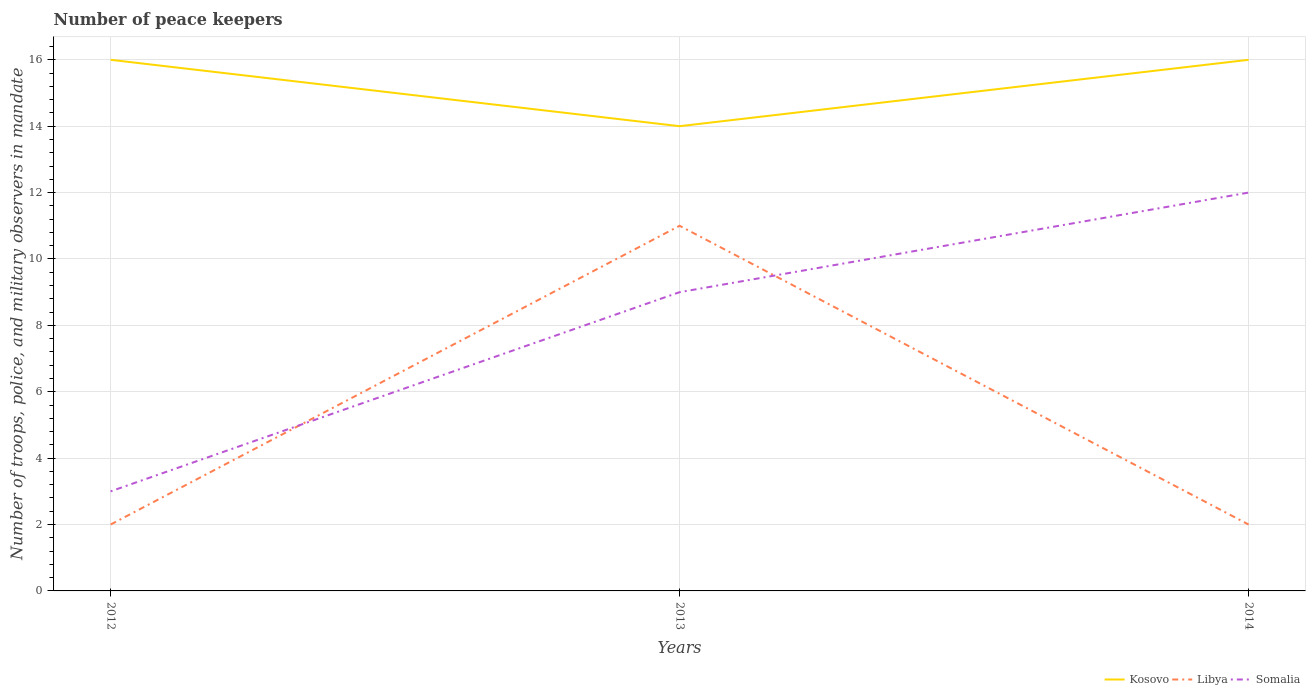How many different coloured lines are there?
Provide a short and direct response. 3. Does the line corresponding to Kosovo intersect with the line corresponding to Libya?
Give a very brief answer. No. In which year was the number of peace keepers in in Somalia maximum?
Your answer should be very brief. 2012. What is the total number of peace keepers in in Somalia in the graph?
Offer a terse response. -6. What is the difference between the highest and the second highest number of peace keepers in in Somalia?
Your answer should be compact. 9. How many years are there in the graph?
Provide a succinct answer. 3. What is the difference between two consecutive major ticks on the Y-axis?
Your answer should be compact. 2. Does the graph contain grids?
Ensure brevity in your answer.  Yes. Where does the legend appear in the graph?
Offer a very short reply. Bottom right. How many legend labels are there?
Provide a short and direct response. 3. What is the title of the graph?
Offer a very short reply. Number of peace keepers. Does "Namibia" appear as one of the legend labels in the graph?
Your answer should be very brief. No. What is the label or title of the X-axis?
Offer a terse response. Years. What is the label or title of the Y-axis?
Give a very brief answer. Number of troops, police, and military observers in mandate. What is the Number of troops, police, and military observers in mandate of Kosovo in 2012?
Give a very brief answer. 16. What is the Number of troops, police, and military observers in mandate of Libya in 2012?
Offer a very short reply. 2. What is the Number of troops, police, and military observers in mandate of Somalia in 2012?
Provide a short and direct response. 3. What is the Number of troops, police, and military observers in mandate in Kosovo in 2013?
Offer a terse response. 14. What is the Number of troops, police, and military observers in mandate in Libya in 2013?
Your answer should be compact. 11. What is the Number of troops, police, and military observers in mandate in Libya in 2014?
Offer a terse response. 2. Across all years, what is the maximum Number of troops, police, and military observers in mandate of Libya?
Offer a very short reply. 11. Across all years, what is the minimum Number of troops, police, and military observers in mandate of Libya?
Keep it short and to the point. 2. What is the total Number of troops, police, and military observers in mandate in Somalia in the graph?
Offer a very short reply. 24. What is the difference between the Number of troops, police, and military observers in mandate of Somalia in 2012 and that in 2013?
Ensure brevity in your answer.  -6. What is the difference between the Number of troops, police, and military observers in mandate of Kosovo in 2012 and that in 2014?
Your response must be concise. 0. What is the difference between the Number of troops, police, and military observers in mandate of Libya in 2012 and that in 2014?
Keep it short and to the point. 0. What is the difference between the Number of troops, police, and military observers in mandate in Somalia in 2012 and that in 2014?
Provide a short and direct response. -9. What is the difference between the Number of troops, police, and military observers in mandate in Kosovo in 2012 and the Number of troops, police, and military observers in mandate in Libya in 2013?
Make the answer very short. 5. What is the difference between the Number of troops, police, and military observers in mandate in Kosovo in 2012 and the Number of troops, police, and military observers in mandate in Somalia in 2013?
Keep it short and to the point. 7. What is the difference between the Number of troops, police, and military observers in mandate in Kosovo in 2012 and the Number of troops, police, and military observers in mandate in Somalia in 2014?
Your response must be concise. 4. What is the difference between the Number of troops, police, and military observers in mandate of Kosovo in 2013 and the Number of troops, police, and military observers in mandate of Libya in 2014?
Provide a succinct answer. 12. What is the difference between the Number of troops, police, and military observers in mandate in Libya in 2013 and the Number of troops, police, and military observers in mandate in Somalia in 2014?
Keep it short and to the point. -1. What is the average Number of troops, police, and military observers in mandate of Kosovo per year?
Give a very brief answer. 15.33. In the year 2012, what is the difference between the Number of troops, police, and military observers in mandate in Libya and Number of troops, police, and military observers in mandate in Somalia?
Offer a very short reply. -1. In the year 2013, what is the difference between the Number of troops, police, and military observers in mandate in Libya and Number of troops, police, and military observers in mandate in Somalia?
Keep it short and to the point. 2. In the year 2014, what is the difference between the Number of troops, police, and military observers in mandate in Kosovo and Number of troops, police, and military observers in mandate in Somalia?
Offer a very short reply. 4. What is the ratio of the Number of troops, police, and military observers in mandate in Libya in 2012 to that in 2013?
Your answer should be compact. 0.18. What is the ratio of the Number of troops, police, and military observers in mandate in Somalia in 2012 to that in 2013?
Offer a very short reply. 0.33. What is the ratio of the Number of troops, police, and military observers in mandate in Libya in 2012 to that in 2014?
Give a very brief answer. 1. What is the ratio of the Number of troops, police, and military observers in mandate in Somalia in 2012 to that in 2014?
Provide a short and direct response. 0.25. What is the ratio of the Number of troops, police, and military observers in mandate in Libya in 2013 to that in 2014?
Your response must be concise. 5.5. What is the difference between the highest and the second highest Number of troops, police, and military observers in mandate in Somalia?
Provide a succinct answer. 3. What is the difference between the highest and the lowest Number of troops, police, and military observers in mandate in Kosovo?
Provide a succinct answer. 2. What is the difference between the highest and the lowest Number of troops, police, and military observers in mandate of Libya?
Your answer should be compact. 9. What is the difference between the highest and the lowest Number of troops, police, and military observers in mandate of Somalia?
Ensure brevity in your answer.  9. 